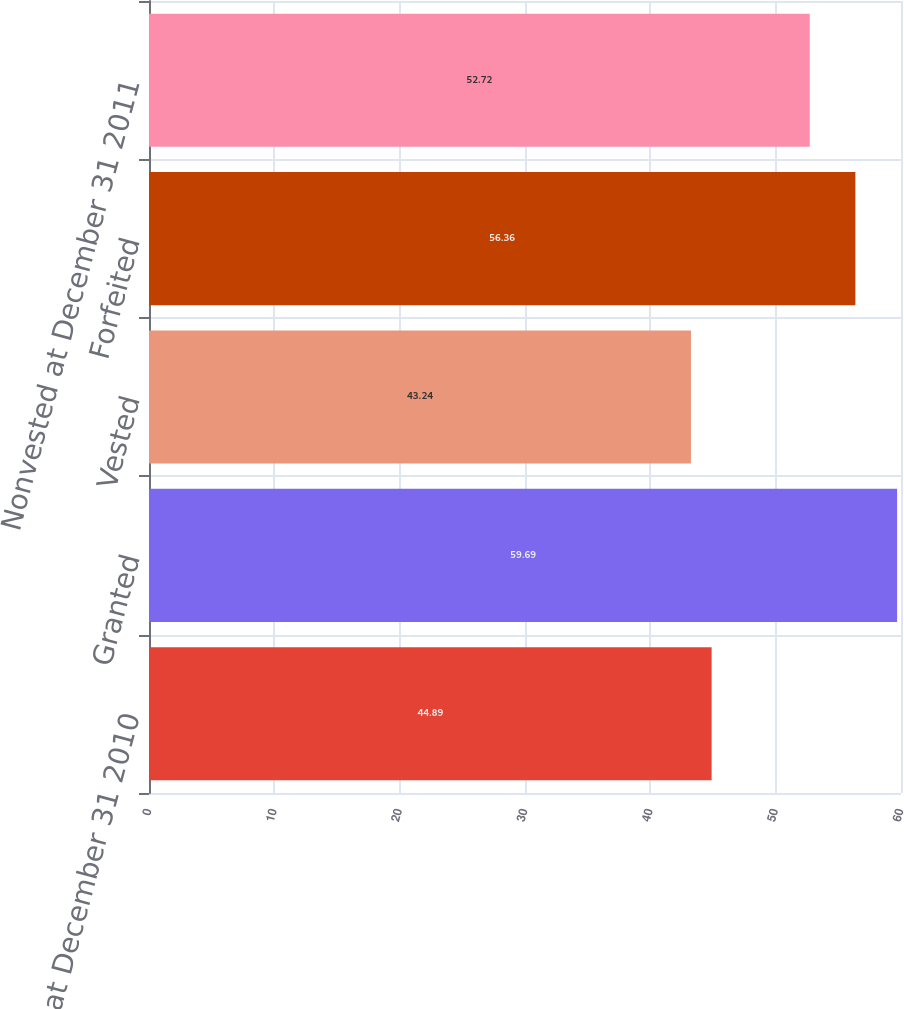<chart> <loc_0><loc_0><loc_500><loc_500><bar_chart><fcel>Nonvested at December 31 2010<fcel>Granted<fcel>Vested<fcel>Forfeited<fcel>Nonvested at December 31 2011<nl><fcel>44.89<fcel>59.69<fcel>43.24<fcel>56.36<fcel>52.72<nl></chart> 